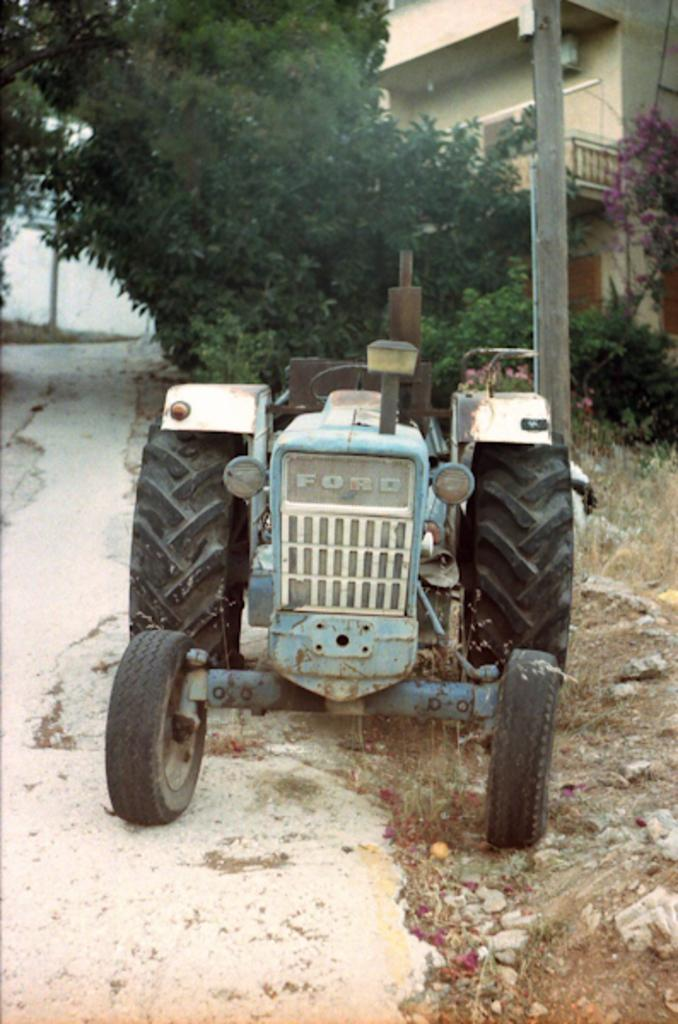What is the main subject in the center of the image? There is a tractor in the center of the image. What can be seen in the background of the image? Trees, plants, grass, flowers, stones, a building, a wall, a fence, a pole, and a road are visible in the background of the image. Where is the harbor located in the image? There is no harbor present in the image. What type of fire can be seen in the image? There is no fire present in the image. 